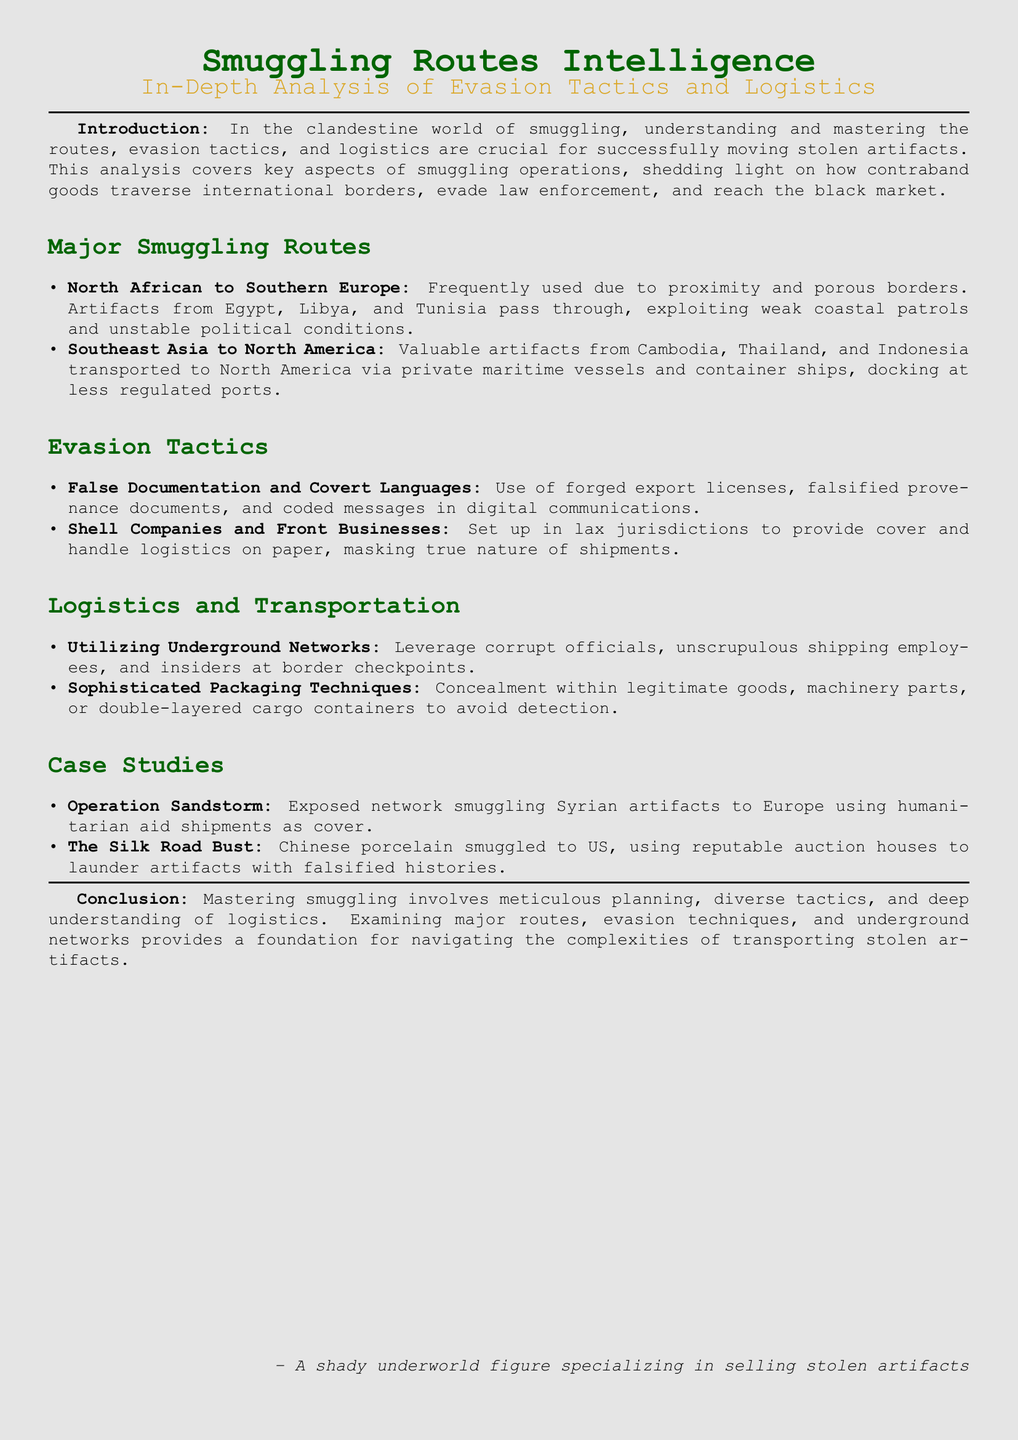what is the title of the document? The title is presented prominently at the beginning of the document, indicating the main focus of the analysis.
Answer: Smuggling Routes Intelligence what are the major smuggling routes mentioned? The document lists key smuggling routes under a dedicated section, highlighting the most significant ones.
Answer: North African to Southern Europe, Southeast Asia to North America what evasion tactic involves the use of fake documents? This tactic is specifically listed in the evasion tactics section, emphasizing its importance in smuggling operations.
Answer: False Documentation and Covert Languages how are artifacts concealed during transportation? The logistics section details techniques used for concealment of artifacts, indicating practical methods employed.
Answer: Sophisticated Packaging Techniques what was Operation Sandstorm focused on? The case studies section briefly describes each operation, including the focus of Operation Sandstorm.
Answer: Smuggling Syrian artifacts to Europe which country’s artifacts are associated with The Silk Road Bust? This case study provides specific information about the artifacts' origin, detailing the operation's context.
Answer: China what type of businesses do smugglers use for cover? The document identifies a specific kind of business structure used to mask illegal activities within smuggling operations.
Answer: Shell Companies and Front Businesses who is the intended audience of this analysis? The final notes of the document suggest the audience likely involves those interested in or involved in the smuggling of artifacts.
Answer: A shady underworld figure specializing in selling stolen artifacts 